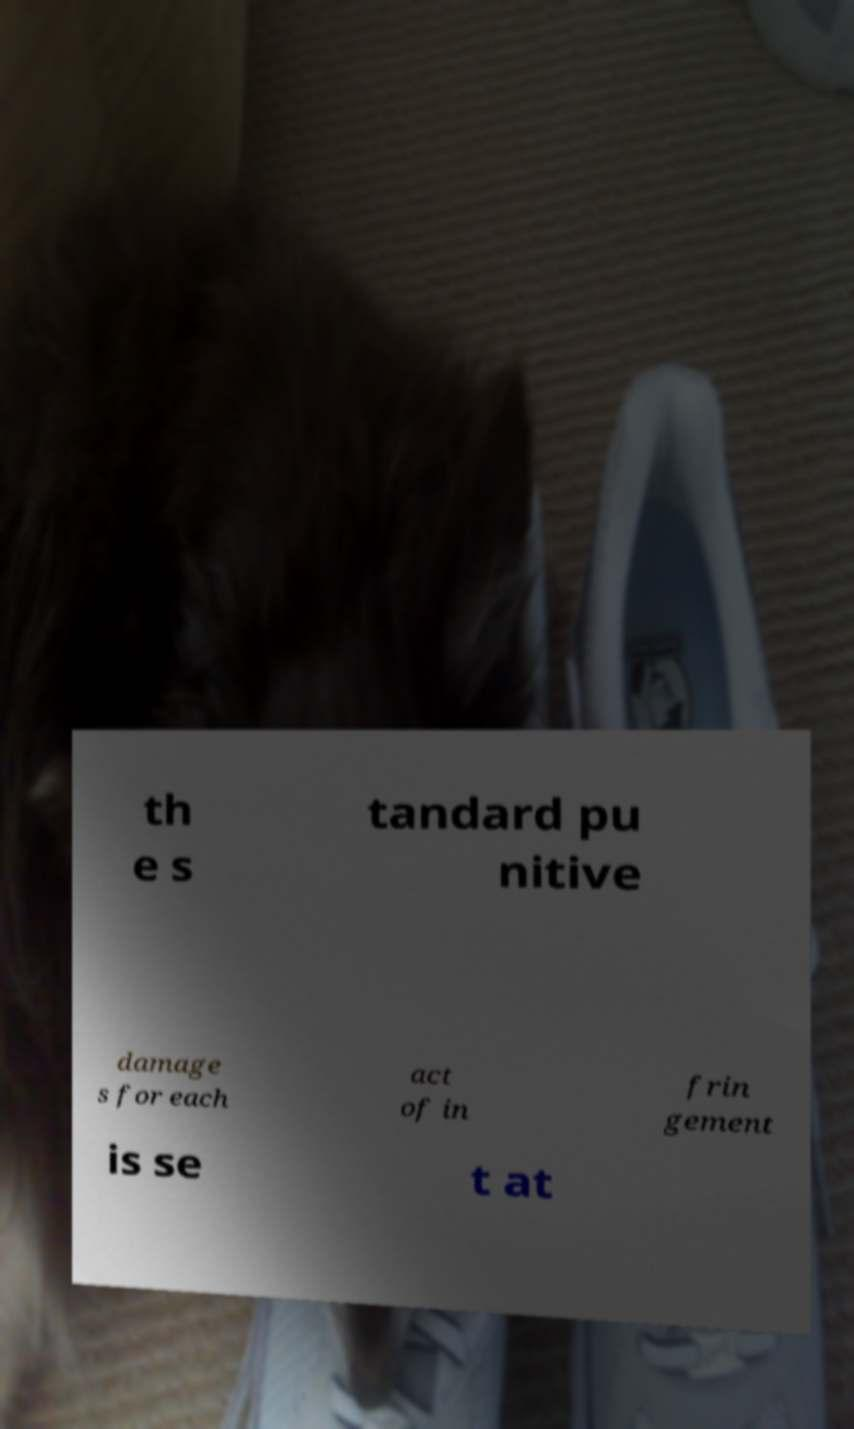What messages or text are displayed in this image? I need them in a readable, typed format. th e s tandard pu nitive damage s for each act of in frin gement is se t at 